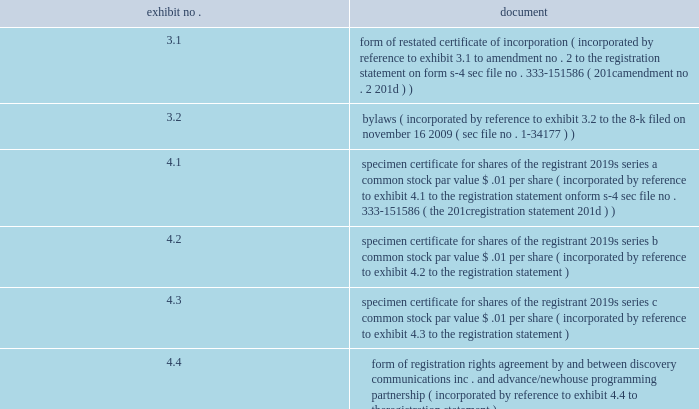The following exhibits are filed as part of this annual report on form 10-k pursuant to item 601 of sec regulation s-k and item 15 ( b ) of form 10-k : exhibit no .
Document 3.1 form of restated certificate of incorporation ( incorporated by reference to exhibit 3.1 to amendment no .
2 to the registration statement on form s-4 , sec file no .
333-151586 ( 201camendment no .
2 201d ) ) .
4.1 specimen certificate for shares of the registrant 2019s series a common stock , par value $ .01 per share ( incorporated by reference to exhibit 4.1 to the registration statement on form s-4 , sec file no .
333-151586 ( the 201cregistration statement 201d ) ) 4.2 specimen certificate for shares of the registrant 2019s series b common stock , par value $ .01 per share ( incorporated by reference to exhibit 4.2 to the registration statement ) 4.3 specimen certificate for shares of the registrant 2019s series c common stock , par value $ .01 per share ( incorporated by reference to exhibit 4.3 to the registration statement ) 4.4 form of registration rights agreement , by and between discovery communications , inc .
And advance/newhouse programming partnership ( incorporated by reference to exhibit 4.4 to the registration statement ) 4.5 form of rights agreement , by and between discovery communications , inc .
And computershare trust company , n.a. , as rights agent ( incorporated by reference to exhibit 4.5 to the registration statement ) 4.6 amendment no .
1 to rights agreement between discovery communications , inc .
And computershare trust company , n.a .
Dated december 10 , 2008 ( incorporated by reference to exhibit 4.1 to the 8-k filed on december 11 , 2008 ) 4.7 amendment and restatement agreement regarding $ 700000000 senior unsecured notes , dated as of november 4 , 2005 , between discovery communications , inc .
And the holders of notes listed therein , and attached thereto , the amended and restated note purchase agreement , dated as of november 4 , 2005 , between discovery communications , inc .
And the holders of notes listed therein as purchasers ( the 201c2001 note purchase agreement 201d ) ( incorporated by reference to exhibit 4.7 to the registration statement ) 4.8 first amendment to 2001 note purchase agreement , dated as of april 11 , 2007 , between discovery communications , inc .
And the holders of notes listed therein as noteholders ( incorporated by reference to exhibit 4.8 to the registration statement ) 4.9 amendment and restatement agreement regarding $ 290000000 senior unsecured notes , dated as of november 4 , 2005 , between discovery communications , inc .
And the holders of notes listed therein , and attached thereto , the amended and restated note purchase agreement dated as of november 4 , 2005 , between discovery communications , inc .
And the holders of notes listed therein as purchasers ( the 201c2002 note purchase agreement 201d ) ( incorporated by reference to exhibit 4.9 to the registration statement ) 4.10 first amendment to 2002 note purchase agreement dated as of april 11 , 2007 , between discovery communications , inc .
And the holders of notes listed therein as noteholders ( incorporated by reference to exhibit 4.10 to the registration statement ) 4.11 note purchase agreement , dated as of december 1 , 2005 , between discovery communications , inc .
And the holders of notes listed therein as purchasers ( the 201c2005 note purchase agreement 201d ) ( incorporated by reference to exhibit 4.11 to the registration statement ) 4.12 first amendment to 2005 note purchase agreement , dated as of april 11 , 2007 , between discovery communications , inc .
And the holders of notes listed therein as noteholders ( incorporated by reference to exhibit 4.12 to the registration statement ) .
What is the size difference between the senior unsecured note amounts between those under the 2001 note purchase agreement and those under the 2002 note purchase agreement? 
Computations: (700000000 - 290000000)
Answer: 410000000.0. 